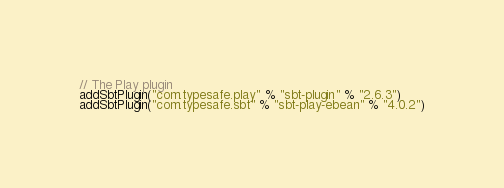Convert code to text. <code><loc_0><loc_0><loc_500><loc_500><_Scala_>// The Play plugin
addSbtPlugin("com.typesafe.play" % "sbt-plugin" % "2.6.3")
addSbtPlugin("com.typesafe.sbt" % "sbt-play-ebean" % "4.0.2")
</code> 